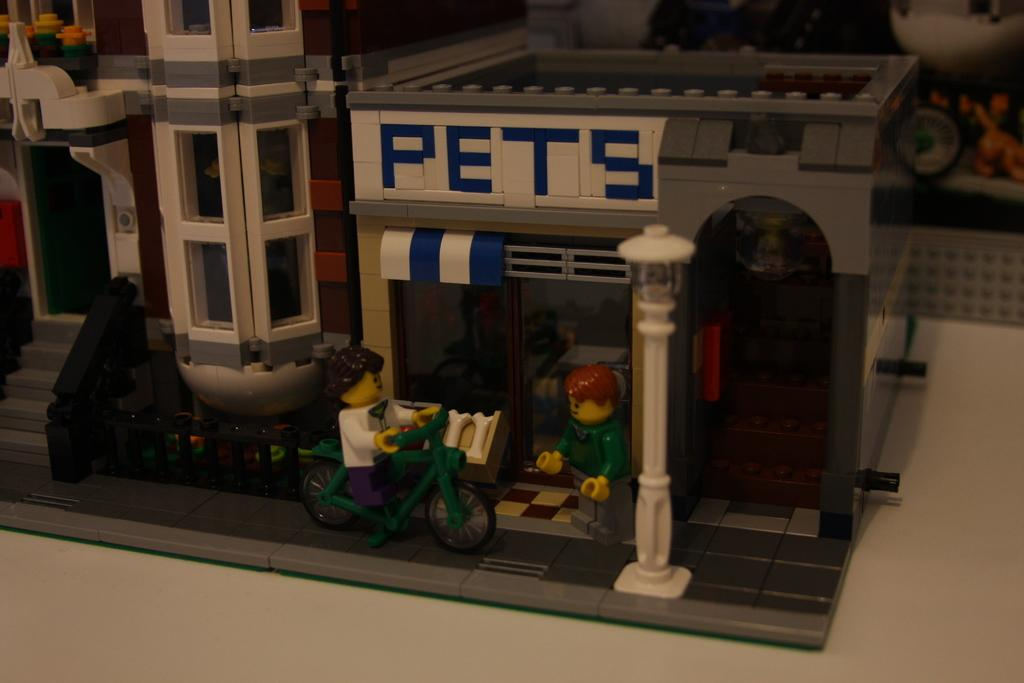What is the main object in the image? There is a toy house in the image. Who is present in the image? There is a boy in the image. What is the boy doing in the image? The boy is sitting on a cycle. How many tomatoes are hanging from the toy house in the image? There are no tomatoes present in the image, as it features a toy house and a boy sitting on a cycle. 